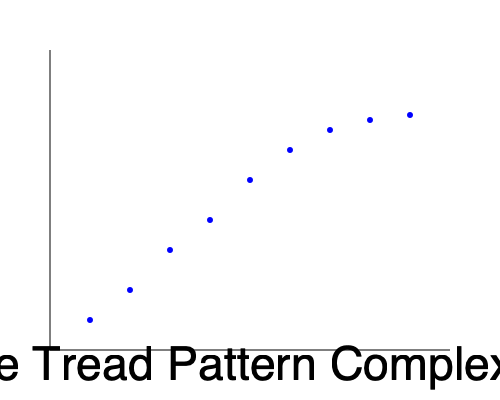As a product planner analyzing the relationship between tire tread pattern complexity and overall performance scores, what conclusion can be drawn from the scatter plot? How might this information influence tire design decisions for performance-oriented vehicles? To answer this question, we need to analyze the scatter plot and interpret the relationship between tire tread pattern complexity and performance scores. Let's break it down step-by-step:

1. Observe the overall trend:
   The scatter plot shows a clear positive correlation between tire tread pattern complexity and performance scores. As the complexity increases along the x-axis, the performance scores generally increase along the y-axis.

2. Analyze the rate of change:
   The relationship appears to be non-linear. The performance score increases more rapidly at lower complexity levels and then begins to level off at higher complexity levels.

3. Identify the point of diminishing returns:
   Around the middle to upper range of complexity, the rate of performance improvement starts to decrease. This suggests a point of diminishing returns where further increases in complexity yield smaller performance gains.

4. Consider the implications for tire design:
   a. Performance-oriented vehicles would benefit from more complex tread patterns, but only up to a certain point.
   b. There may be an optimal range of complexity that balances performance gains with other factors such as manufacturing costs, noise levels, and tire longevity.
   c. Extremely complex tread patterns may not provide significant additional performance benefits and could potentially introduce other drawbacks.

5. Think about the product planning perspective:
   a. This data suggests that investing in moderately complex tread patterns could yield the best balance of performance and cost-effectiveness.
   b. For high-performance vehicles, targeting the "sweet spot" just before the curve levels off could be ideal.
   c. Entry-level performance models might benefit most from the steeper performance gains in the lower to mid-range of complexity.

Conclusion: The scatter plot indicates a positive but non-linear relationship between tire tread pattern complexity and performance scores, with diminishing returns at higher complexity levels. This information can guide tire design decisions by helping to identify the optimal range of tread pattern complexity for different vehicle segments and performance targets.
Answer: Positive non-linear relationship with diminishing returns; optimal complexity range exists for balancing performance and cost-effectiveness in tire design. 